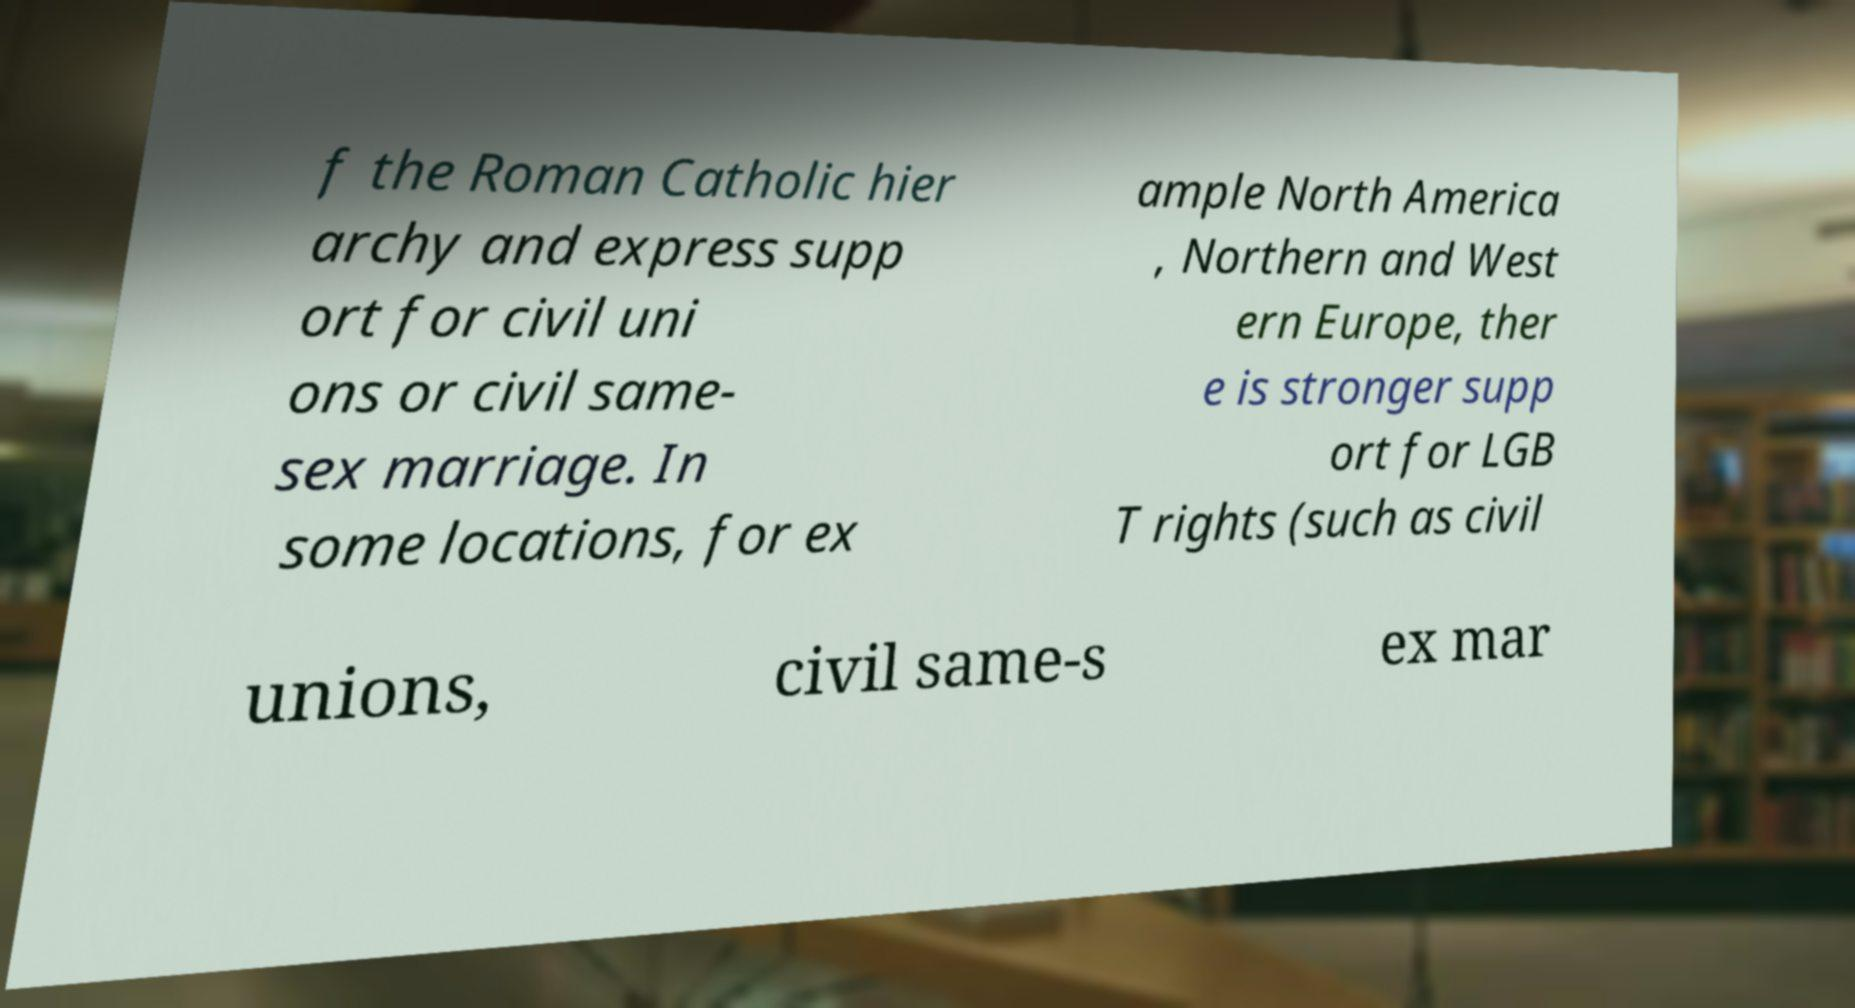Can you read and provide the text displayed in the image?This photo seems to have some interesting text. Can you extract and type it out for me? f the Roman Catholic hier archy and express supp ort for civil uni ons or civil same- sex marriage. In some locations, for ex ample North America , Northern and West ern Europe, ther e is stronger supp ort for LGB T rights (such as civil unions, civil same-s ex mar 